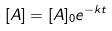<formula> <loc_0><loc_0><loc_500><loc_500>[ A ] = [ A ] _ { 0 } e ^ { - k t }</formula> 